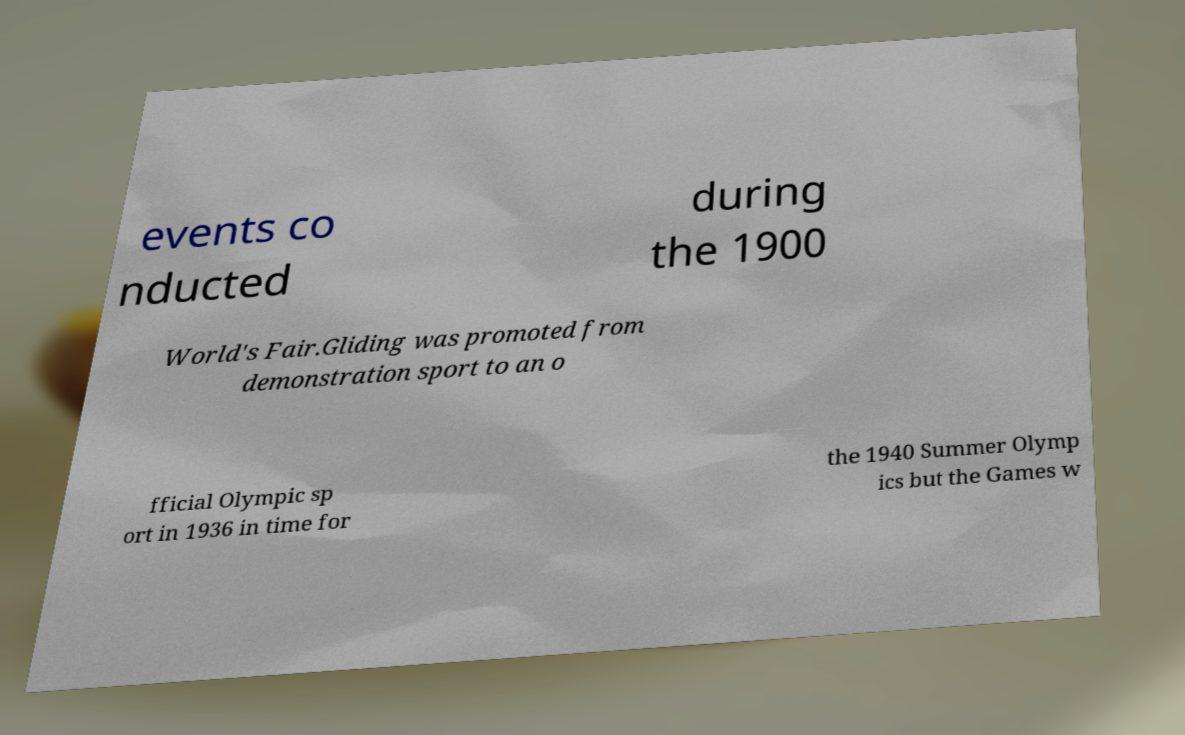Can you accurately transcribe the text from the provided image for me? events co nducted during the 1900 World's Fair.Gliding was promoted from demonstration sport to an o fficial Olympic sp ort in 1936 in time for the 1940 Summer Olymp ics but the Games w 